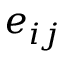Convert formula to latex. <formula><loc_0><loc_0><loc_500><loc_500>e _ { i j }</formula> 